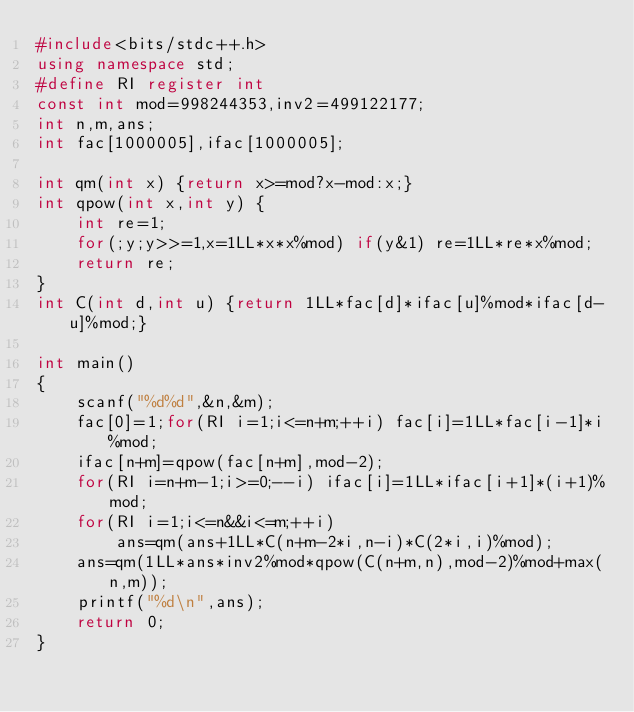Convert code to text. <code><loc_0><loc_0><loc_500><loc_500><_C++_>#include<bits/stdc++.h>
using namespace std;
#define RI register int
const int mod=998244353,inv2=499122177;
int n,m,ans;
int fac[1000005],ifac[1000005];

int qm(int x) {return x>=mod?x-mod:x;}
int qpow(int x,int y) {
	int re=1;
	for(;y;y>>=1,x=1LL*x*x%mod) if(y&1) re=1LL*re*x%mod;
	return re;
}
int C(int d,int u) {return 1LL*fac[d]*ifac[u]%mod*ifac[d-u]%mod;}

int main()
{
	scanf("%d%d",&n,&m);
	fac[0]=1;for(RI i=1;i<=n+m;++i) fac[i]=1LL*fac[i-1]*i%mod;
	ifac[n+m]=qpow(fac[n+m],mod-2);
	for(RI i=n+m-1;i>=0;--i) ifac[i]=1LL*ifac[i+1]*(i+1)%mod;
	for(RI i=1;i<=n&&i<=m;++i)
		ans=qm(ans+1LL*C(n+m-2*i,n-i)*C(2*i,i)%mod);
	ans=qm(1LL*ans*inv2%mod*qpow(C(n+m,n),mod-2)%mod+max(n,m));
	printf("%d\n",ans);
	return 0;
}</code> 